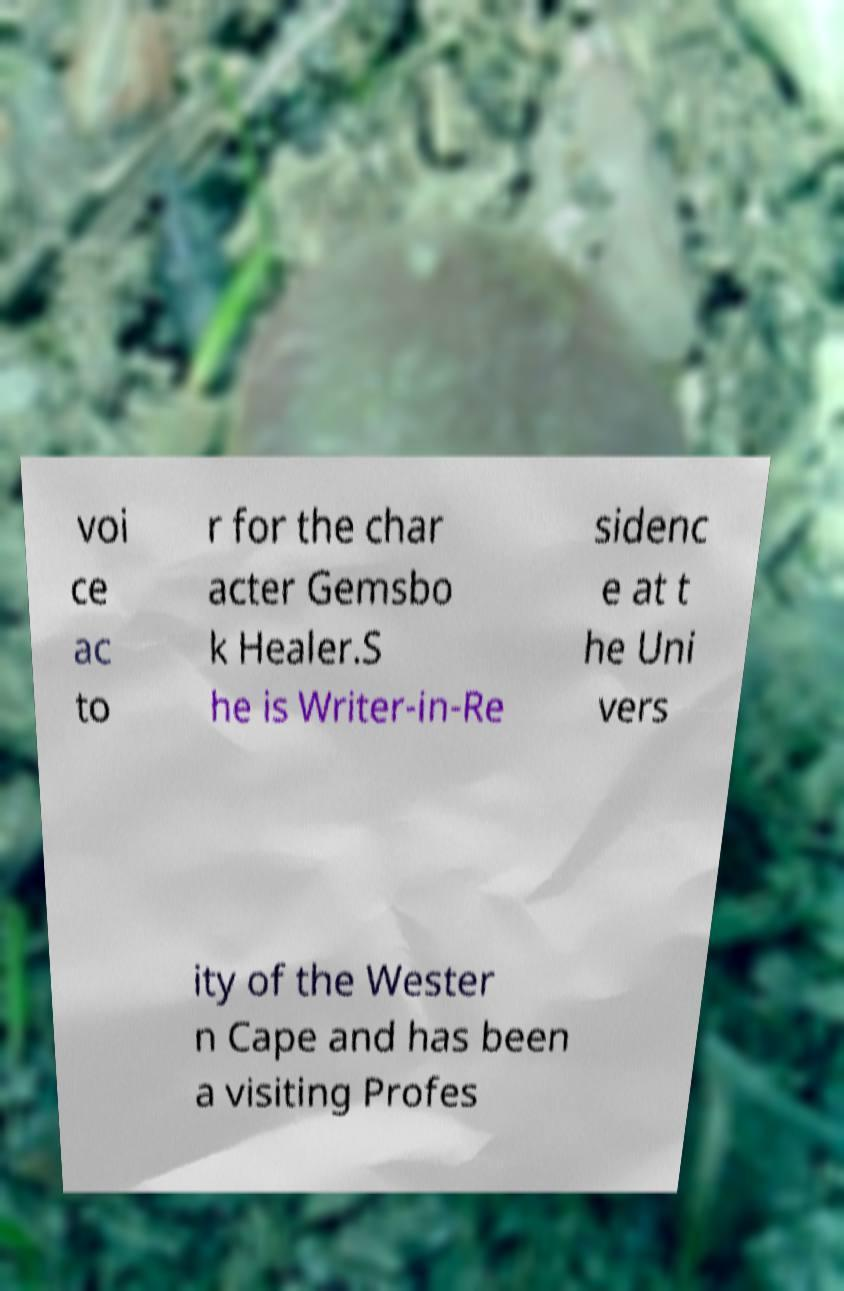Could you assist in decoding the text presented in this image and type it out clearly? voi ce ac to r for the char acter Gemsbo k Healer.S he is Writer-in-Re sidenc e at t he Uni vers ity of the Wester n Cape and has been a visiting Profes 